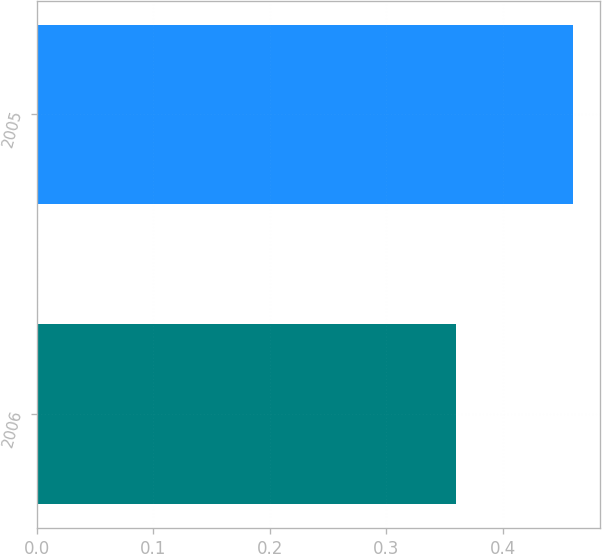Convert chart to OTSL. <chart><loc_0><loc_0><loc_500><loc_500><bar_chart><fcel>2006<fcel>2005<nl><fcel>0.36<fcel>0.46<nl></chart> 